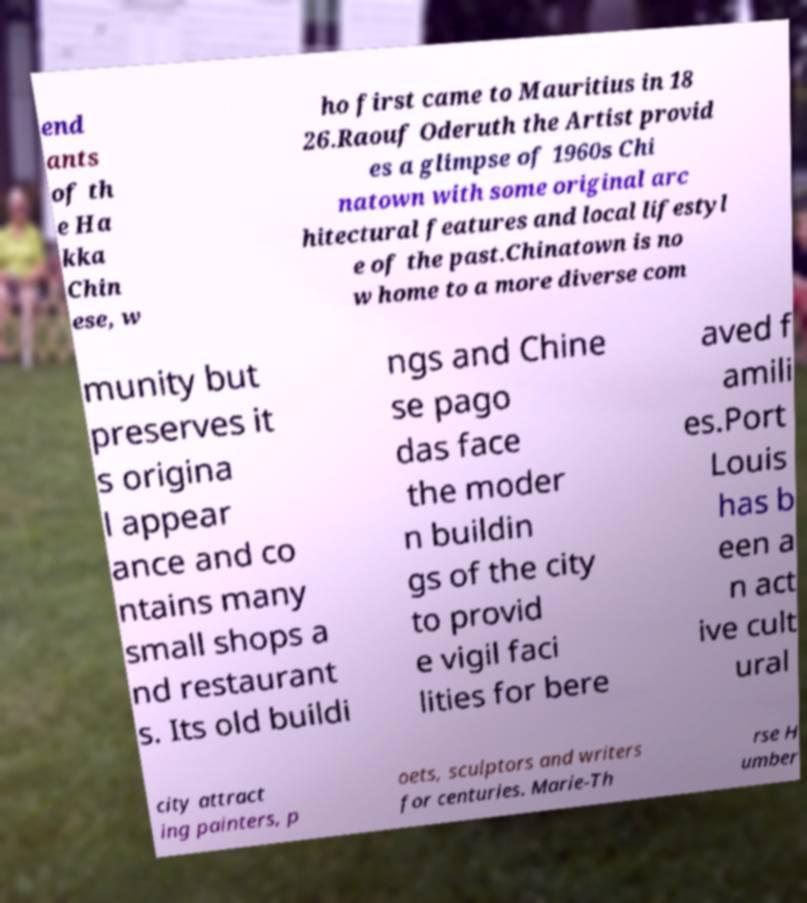There's text embedded in this image that I need extracted. Can you transcribe it verbatim? end ants of th e Ha kka Chin ese, w ho first came to Mauritius in 18 26.Raouf Oderuth the Artist provid es a glimpse of 1960s Chi natown with some original arc hitectural features and local lifestyl e of the past.Chinatown is no w home to a more diverse com munity but preserves it s origina l appear ance and co ntains many small shops a nd restaurant s. Its old buildi ngs and Chine se pago das face the moder n buildin gs of the city to provid e vigil faci lities for bere aved f amili es.Port Louis has b een a n act ive cult ural city attract ing painters, p oets, sculptors and writers for centuries. Marie-Th rse H umber 